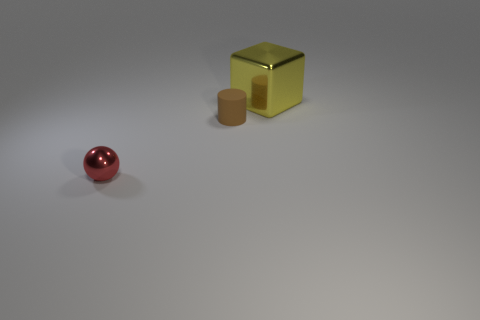There is a object that is behind the ball and left of the big yellow object; what is its material?
Your answer should be compact. Rubber. What number of other tiny shiny things are the same shape as the small brown thing?
Provide a short and direct response. 0. There is a metal thing that is behind the tiny object to the left of the tiny thing that is to the right of the small red thing; what is its size?
Your response must be concise. Large. Are there more small red metal spheres that are behind the small rubber thing than yellow cubes?
Keep it short and to the point. No. Are there any tiny blue things?
Offer a very short reply. No. How many cubes are the same size as the sphere?
Provide a succinct answer. 0. Are there more small shiny things in front of the small red ball than tiny metallic spheres right of the big yellow metal block?
Make the answer very short. No. There is a object that is the same size as the red sphere; what is it made of?
Give a very brief answer. Rubber. What is the shape of the brown matte object?
Your answer should be very brief. Cylinder. What number of yellow objects are large shiny objects or tiny cylinders?
Your answer should be compact. 1. 